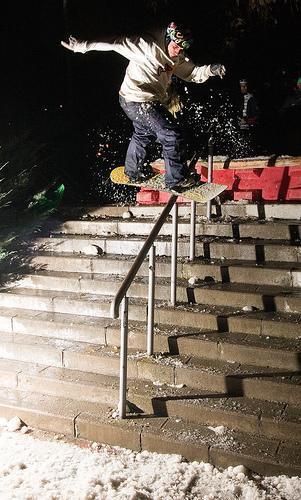How many steps of stairs are there?
Give a very brief answer. 10. How many people are in the picture?
Give a very brief answer. 1. 